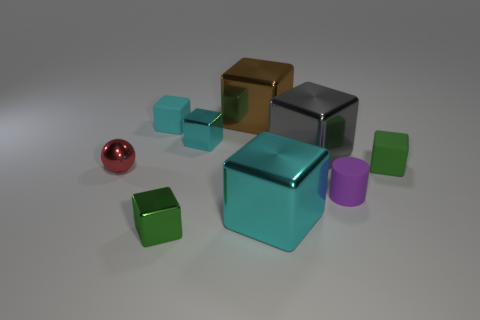Subtract all yellow cylinders. How many cyan cubes are left? 3 Subtract 3 blocks. How many blocks are left? 4 Subtract all green rubber blocks. How many blocks are left? 6 Subtract all cyan blocks. How many blocks are left? 4 Subtract all brown blocks. Subtract all blue cylinders. How many blocks are left? 6 Subtract all cylinders. How many objects are left? 8 Subtract all small cyan cubes. Subtract all cyan rubber blocks. How many objects are left? 6 Add 2 brown shiny objects. How many brown shiny objects are left? 3 Add 4 green spheres. How many green spheres exist? 4 Subtract 0 blue cylinders. How many objects are left? 9 